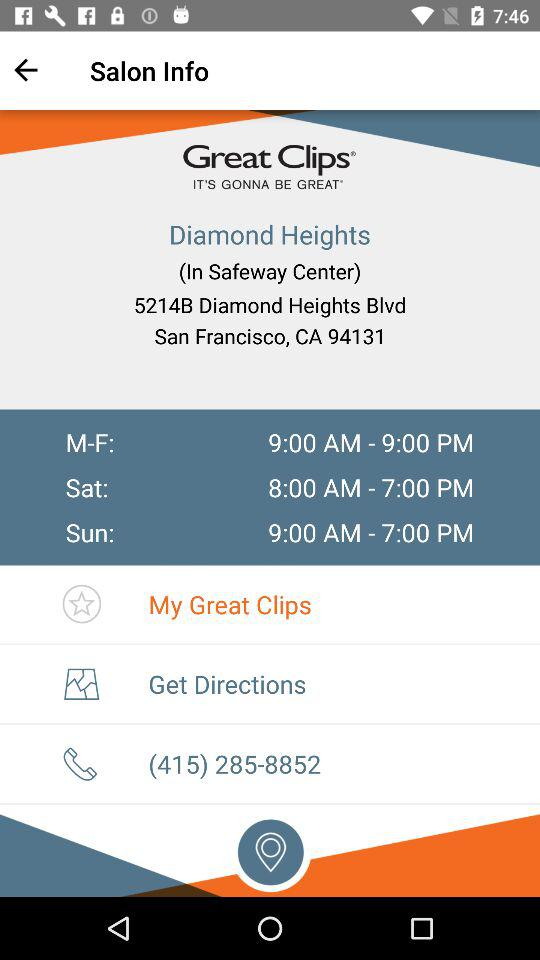What is the helpline number? The helpline number is (415) 285-8852. 